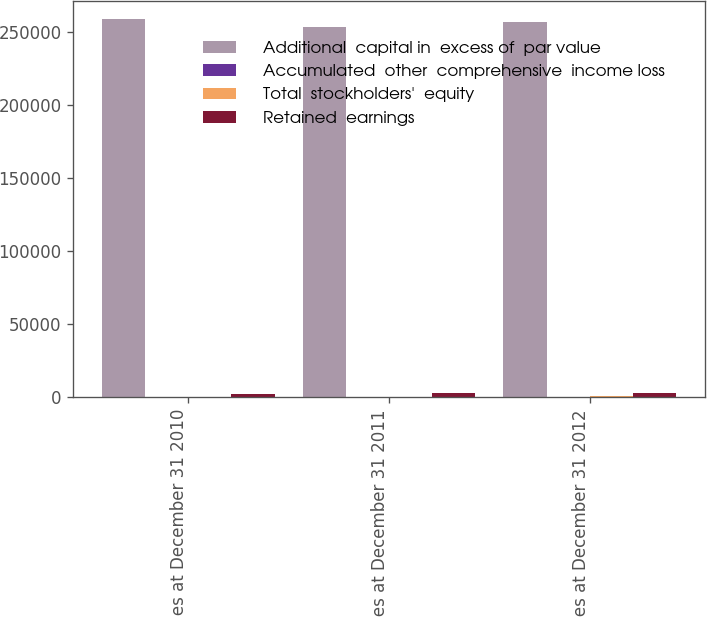Convert chart. <chart><loc_0><loc_0><loc_500><loc_500><stacked_bar_chart><ecel><fcel>Balances at December 31 2010<fcel>Balances at December 31 2011<fcel>Balances at December 31 2012<nl><fcel>Additional  capital in  excess of  par value<fcel>258760<fcel>253272<fcel>257018<nl><fcel>Accumulated  other  comprehensive  income loss<fcel>51.7<fcel>50.7<fcel>51.4<nl><fcel>Total  stockholders'  equity<fcel>506.3<fcel>502<fcel>631<nl><fcel>Retained  earnings<fcel>2599.4<fcel>2765.2<fcel>3031.8<nl></chart> 